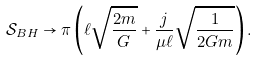<formula> <loc_0><loc_0><loc_500><loc_500>\mathcal { S } _ { B H } \rightarrow \pi \left ( \ell \sqrt { \frac { 2 m } { G } } + \frac { j } { \mu \ell } \sqrt { \frac { 1 } { 2 G m } } \right ) .</formula> 